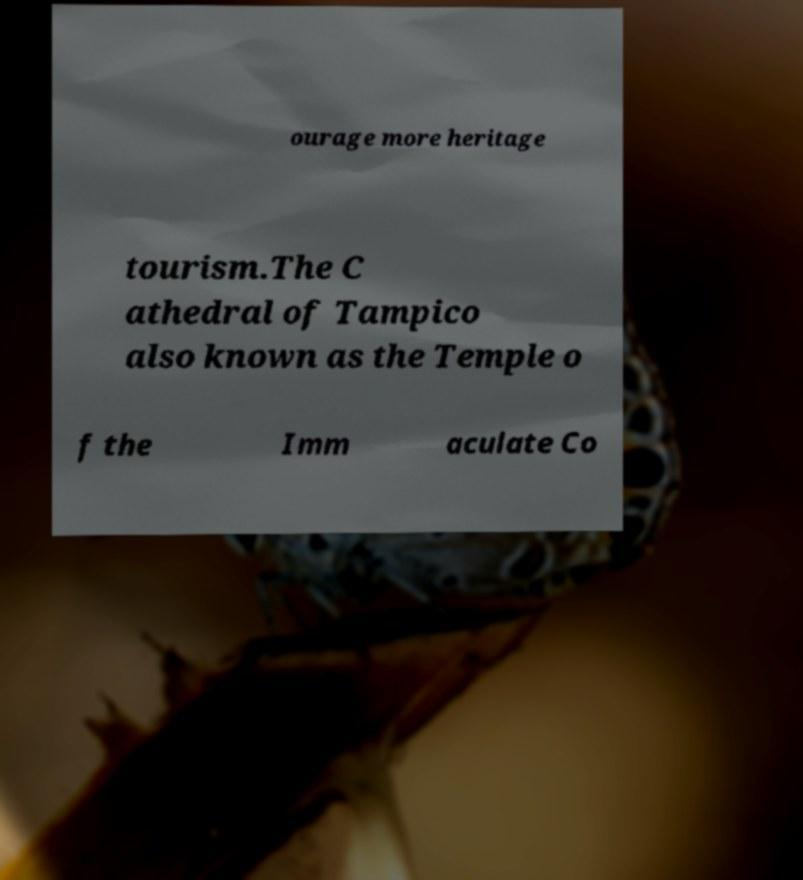Could you assist in decoding the text presented in this image and type it out clearly? ourage more heritage tourism.The C athedral of Tampico also known as the Temple o f the Imm aculate Co 